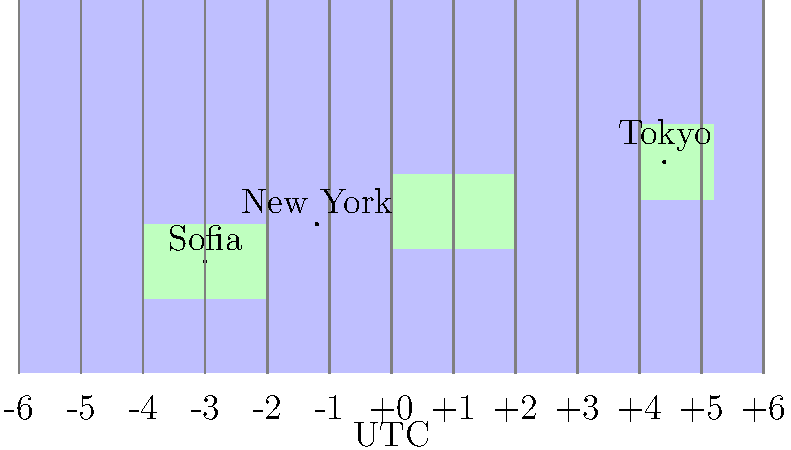As a legal translator working on an international case, you need to calculate a deadline for submitting documents. The deadline is set at 11:59 PM UTC on a Friday. If you're based in Sofia and need to ensure the documents reach both New York and Tokyo offices by their local deadlines, by what time (in Sofia) should you submit the documents? Assume instant transmission and use the map to determine time zones. Let's approach this step-by-step:

1. Identify time zones from the map:
   Sofia: UTC+2
   New York: UTC-5
   Tokyo: UTC+9

2. Calculate local times for the 11:59 PM UTC deadline:
   Sofia: 11:59 PM UTC + 2 hours = 1:59 AM Saturday (next day)
   New York: 11:59 PM UTC - 5 hours = 6:59 PM Friday
   Tokyo: 11:59 PM UTC + 9 hours = 8:59 AM Saturday (next day)

3. Determine the earliest deadline:
   The earliest deadline is in New York at 6:59 PM Friday local time.

4. Convert New York deadline to Sofia time:
   Time difference between Sofia and New York: 7 hours
   6:59 PM Friday in New York = 1:59 AM Saturday in Sofia

5. Allow for processing time:
   To ensure timely submission, it's advisable to submit at least an hour earlier.

Therefore, you should submit the documents by 12:59 AM Saturday, Sofia time, to meet all deadlines comfortably.
Answer: 12:59 AM Saturday, Sofia time 